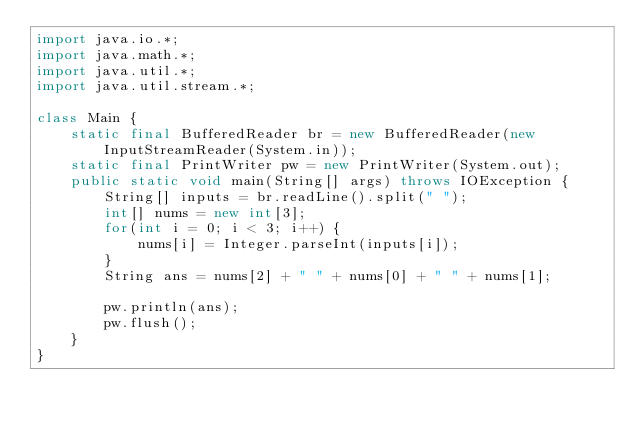Convert code to text. <code><loc_0><loc_0><loc_500><loc_500><_Java_>import java.io.*;
import java.math.*;
import java.util.*;
import java.util.stream.*;

class Main {
    static final BufferedReader br = new BufferedReader(new InputStreamReader(System.in));
    static final PrintWriter pw = new PrintWriter(System.out);
    public static void main(String[] args) throws IOException {
        String[] inputs = br.readLine().split(" ");
        int[] nums = new int[3];
        for(int i = 0; i < 3; i++) {
            nums[i] = Integer.parseInt(inputs[i]);
        }
        String ans = nums[2] + " " + nums[0] + " " + nums[1];

        pw.println(ans);
        pw.flush();
    }
}
</code> 